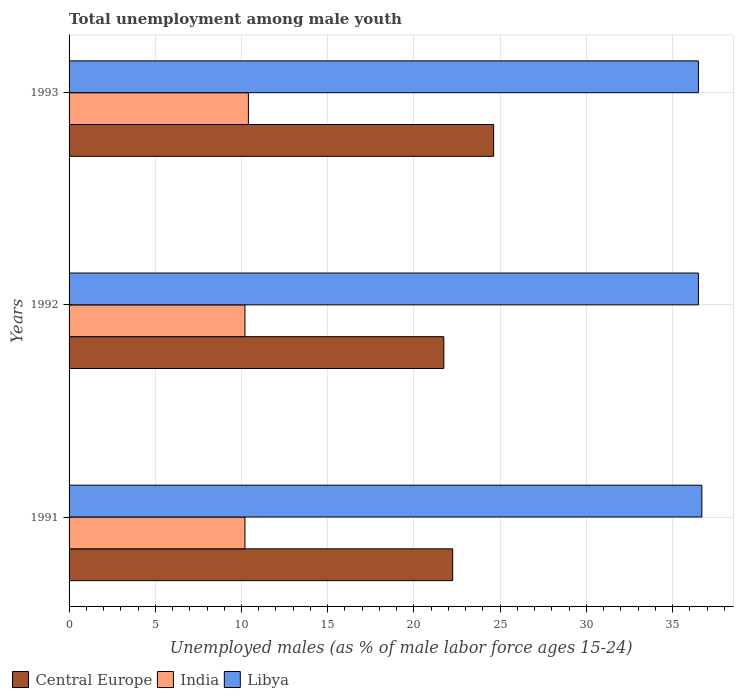How many different coloured bars are there?
Your answer should be compact. 3. How many groups of bars are there?
Give a very brief answer. 3. Are the number of bars per tick equal to the number of legend labels?
Give a very brief answer. Yes. Are the number of bars on each tick of the Y-axis equal?
Ensure brevity in your answer.  Yes. How many bars are there on the 2nd tick from the top?
Your answer should be compact. 3. What is the percentage of unemployed males in in Central Europe in 1991?
Offer a terse response. 22.25. Across all years, what is the maximum percentage of unemployed males in in Central Europe?
Make the answer very short. 24.62. Across all years, what is the minimum percentage of unemployed males in in Libya?
Your answer should be compact. 36.5. In which year was the percentage of unemployed males in in India maximum?
Your answer should be very brief. 1993. What is the total percentage of unemployed males in in India in the graph?
Offer a terse response. 30.8. What is the difference between the percentage of unemployed males in in Central Europe in 1991 and that in 1992?
Your answer should be very brief. 0.51. What is the difference between the percentage of unemployed males in in Central Europe in 1993 and the percentage of unemployed males in in India in 1992?
Your answer should be very brief. 14.42. What is the average percentage of unemployed males in in Central Europe per year?
Make the answer very short. 22.87. In the year 1992, what is the difference between the percentage of unemployed males in in Libya and percentage of unemployed males in in India?
Your response must be concise. 26.3. What is the ratio of the percentage of unemployed males in in Central Europe in 1991 to that in 1992?
Provide a short and direct response. 1.02. Is the percentage of unemployed males in in Central Europe in 1992 less than that in 1993?
Offer a very short reply. Yes. Is the difference between the percentage of unemployed males in in Libya in 1991 and 1992 greater than the difference between the percentage of unemployed males in in India in 1991 and 1992?
Ensure brevity in your answer.  Yes. What is the difference between the highest and the second highest percentage of unemployed males in in Libya?
Your answer should be compact. 0.2. What is the difference between the highest and the lowest percentage of unemployed males in in India?
Offer a very short reply. 0.2. Is the sum of the percentage of unemployed males in in Libya in 1991 and 1992 greater than the maximum percentage of unemployed males in in India across all years?
Provide a succinct answer. Yes. What does the 2nd bar from the top in 1991 represents?
Keep it short and to the point. India. Is it the case that in every year, the sum of the percentage of unemployed males in in Central Europe and percentage of unemployed males in in India is greater than the percentage of unemployed males in in Libya?
Offer a terse response. No. How many bars are there?
Your answer should be compact. 9. Are all the bars in the graph horizontal?
Ensure brevity in your answer.  Yes. How many years are there in the graph?
Your response must be concise. 3. What is the difference between two consecutive major ticks on the X-axis?
Your response must be concise. 5. Are the values on the major ticks of X-axis written in scientific E-notation?
Your answer should be compact. No. Does the graph contain any zero values?
Provide a short and direct response. No. Does the graph contain grids?
Offer a terse response. Yes. How many legend labels are there?
Your answer should be very brief. 3. How are the legend labels stacked?
Offer a very short reply. Horizontal. What is the title of the graph?
Keep it short and to the point. Total unemployment among male youth. What is the label or title of the X-axis?
Provide a succinct answer. Unemployed males (as % of male labor force ages 15-24). What is the label or title of the Y-axis?
Your answer should be very brief. Years. What is the Unemployed males (as % of male labor force ages 15-24) of Central Europe in 1991?
Provide a succinct answer. 22.25. What is the Unemployed males (as % of male labor force ages 15-24) of India in 1991?
Give a very brief answer. 10.2. What is the Unemployed males (as % of male labor force ages 15-24) in Libya in 1991?
Offer a terse response. 36.7. What is the Unemployed males (as % of male labor force ages 15-24) in Central Europe in 1992?
Your answer should be compact. 21.74. What is the Unemployed males (as % of male labor force ages 15-24) of India in 1992?
Provide a short and direct response. 10.2. What is the Unemployed males (as % of male labor force ages 15-24) in Libya in 1992?
Provide a succinct answer. 36.5. What is the Unemployed males (as % of male labor force ages 15-24) in Central Europe in 1993?
Your answer should be very brief. 24.62. What is the Unemployed males (as % of male labor force ages 15-24) of India in 1993?
Offer a very short reply. 10.4. What is the Unemployed males (as % of male labor force ages 15-24) in Libya in 1993?
Your response must be concise. 36.5. Across all years, what is the maximum Unemployed males (as % of male labor force ages 15-24) of Central Europe?
Your answer should be very brief. 24.62. Across all years, what is the maximum Unemployed males (as % of male labor force ages 15-24) in India?
Your answer should be very brief. 10.4. Across all years, what is the maximum Unemployed males (as % of male labor force ages 15-24) of Libya?
Your answer should be very brief. 36.7. Across all years, what is the minimum Unemployed males (as % of male labor force ages 15-24) of Central Europe?
Make the answer very short. 21.74. Across all years, what is the minimum Unemployed males (as % of male labor force ages 15-24) in India?
Offer a terse response. 10.2. Across all years, what is the minimum Unemployed males (as % of male labor force ages 15-24) in Libya?
Give a very brief answer. 36.5. What is the total Unemployed males (as % of male labor force ages 15-24) of Central Europe in the graph?
Offer a terse response. 68.61. What is the total Unemployed males (as % of male labor force ages 15-24) of India in the graph?
Provide a short and direct response. 30.8. What is the total Unemployed males (as % of male labor force ages 15-24) in Libya in the graph?
Your answer should be compact. 109.7. What is the difference between the Unemployed males (as % of male labor force ages 15-24) in Central Europe in 1991 and that in 1992?
Give a very brief answer. 0.51. What is the difference between the Unemployed males (as % of male labor force ages 15-24) of India in 1991 and that in 1992?
Offer a terse response. 0. What is the difference between the Unemployed males (as % of male labor force ages 15-24) in Central Europe in 1991 and that in 1993?
Offer a terse response. -2.37. What is the difference between the Unemployed males (as % of male labor force ages 15-24) in Central Europe in 1992 and that in 1993?
Make the answer very short. -2.89. What is the difference between the Unemployed males (as % of male labor force ages 15-24) in Libya in 1992 and that in 1993?
Give a very brief answer. 0. What is the difference between the Unemployed males (as % of male labor force ages 15-24) of Central Europe in 1991 and the Unemployed males (as % of male labor force ages 15-24) of India in 1992?
Keep it short and to the point. 12.05. What is the difference between the Unemployed males (as % of male labor force ages 15-24) in Central Europe in 1991 and the Unemployed males (as % of male labor force ages 15-24) in Libya in 1992?
Offer a terse response. -14.25. What is the difference between the Unemployed males (as % of male labor force ages 15-24) of India in 1991 and the Unemployed males (as % of male labor force ages 15-24) of Libya in 1992?
Keep it short and to the point. -26.3. What is the difference between the Unemployed males (as % of male labor force ages 15-24) in Central Europe in 1991 and the Unemployed males (as % of male labor force ages 15-24) in India in 1993?
Your answer should be compact. 11.85. What is the difference between the Unemployed males (as % of male labor force ages 15-24) of Central Europe in 1991 and the Unemployed males (as % of male labor force ages 15-24) of Libya in 1993?
Your answer should be compact. -14.25. What is the difference between the Unemployed males (as % of male labor force ages 15-24) in India in 1991 and the Unemployed males (as % of male labor force ages 15-24) in Libya in 1993?
Provide a short and direct response. -26.3. What is the difference between the Unemployed males (as % of male labor force ages 15-24) in Central Europe in 1992 and the Unemployed males (as % of male labor force ages 15-24) in India in 1993?
Provide a succinct answer. 11.34. What is the difference between the Unemployed males (as % of male labor force ages 15-24) in Central Europe in 1992 and the Unemployed males (as % of male labor force ages 15-24) in Libya in 1993?
Ensure brevity in your answer.  -14.76. What is the difference between the Unemployed males (as % of male labor force ages 15-24) in India in 1992 and the Unemployed males (as % of male labor force ages 15-24) in Libya in 1993?
Offer a very short reply. -26.3. What is the average Unemployed males (as % of male labor force ages 15-24) in Central Europe per year?
Keep it short and to the point. 22.87. What is the average Unemployed males (as % of male labor force ages 15-24) of India per year?
Your response must be concise. 10.27. What is the average Unemployed males (as % of male labor force ages 15-24) of Libya per year?
Ensure brevity in your answer.  36.57. In the year 1991, what is the difference between the Unemployed males (as % of male labor force ages 15-24) in Central Europe and Unemployed males (as % of male labor force ages 15-24) in India?
Offer a very short reply. 12.05. In the year 1991, what is the difference between the Unemployed males (as % of male labor force ages 15-24) in Central Europe and Unemployed males (as % of male labor force ages 15-24) in Libya?
Provide a succinct answer. -14.45. In the year 1991, what is the difference between the Unemployed males (as % of male labor force ages 15-24) in India and Unemployed males (as % of male labor force ages 15-24) in Libya?
Your answer should be compact. -26.5. In the year 1992, what is the difference between the Unemployed males (as % of male labor force ages 15-24) of Central Europe and Unemployed males (as % of male labor force ages 15-24) of India?
Your answer should be very brief. 11.54. In the year 1992, what is the difference between the Unemployed males (as % of male labor force ages 15-24) of Central Europe and Unemployed males (as % of male labor force ages 15-24) of Libya?
Provide a succinct answer. -14.76. In the year 1992, what is the difference between the Unemployed males (as % of male labor force ages 15-24) of India and Unemployed males (as % of male labor force ages 15-24) of Libya?
Keep it short and to the point. -26.3. In the year 1993, what is the difference between the Unemployed males (as % of male labor force ages 15-24) in Central Europe and Unemployed males (as % of male labor force ages 15-24) in India?
Your response must be concise. 14.22. In the year 1993, what is the difference between the Unemployed males (as % of male labor force ages 15-24) of Central Europe and Unemployed males (as % of male labor force ages 15-24) of Libya?
Provide a short and direct response. -11.88. In the year 1993, what is the difference between the Unemployed males (as % of male labor force ages 15-24) of India and Unemployed males (as % of male labor force ages 15-24) of Libya?
Offer a terse response. -26.1. What is the ratio of the Unemployed males (as % of male labor force ages 15-24) of Central Europe in 1991 to that in 1992?
Provide a succinct answer. 1.02. What is the ratio of the Unemployed males (as % of male labor force ages 15-24) of India in 1991 to that in 1992?
Your answer should be compact. 1. What is the ratio of the Unemployed males (as % of male labor force ages 15-24) in Libya in 1991 to that in 1992?
Give a very brief answer. 1.01. What is the ratio of the Unemployed males (as % of male labor force ages 15-24) of Central Europe in 1991 to that in 1993?
Your response must be concise. 0.9. What is the ratio of the Unemployed males (as % of male labor force ages 15-24) of India in 1991 to that in 1993?
Give a very brief answer. 0.98. What is the ratio of the Unemployed males (as % of male labor force ages 15-24) in Libya in 1991 to that in 1993?
Your answer should be compact. 1.01. What is the ratio of the Unemployed males (as % of male labor force ages 15-24) of Central Europe in 1992 to that in 1993?
Make the answer very short. 0.88. What is the ratio of the Unemployed males (as % of male labor force ages 15-24) in India in 1992 to that in 1993?
Your answer should be very brief. 0.98. What is the ratio of the Unemployed males (as % of male labor force ages 15-24) in Libya in 1992 to that in 1993?
Keep it short and to the point. 1. What is the difference between the highest and the second highest Unemployed males (as % of male labor force ages 15-24) of Central Europe?
Give a very brief answer. 2.37. What is the difference between the highest and the second highest Unemployed males (as % of male labor force ages 15-24) of India?
Your answer should be compact. 0.2. What is the difference between the highest and the second highest Unemployed males (as % of male labor force ages 15-24) in Libya?
Ensure brevity in your answer.  0.2. What is the difference between the highest and the lowest Unemployed males (as % of male labor force ages 15-24) in Central Europe?
Offer a terse response. 2.89. What is the difference between the highest and the lowest Unemployed males (as % of male labor force ages 15-24) in India?
Provide a succinct answer. 0.2. 